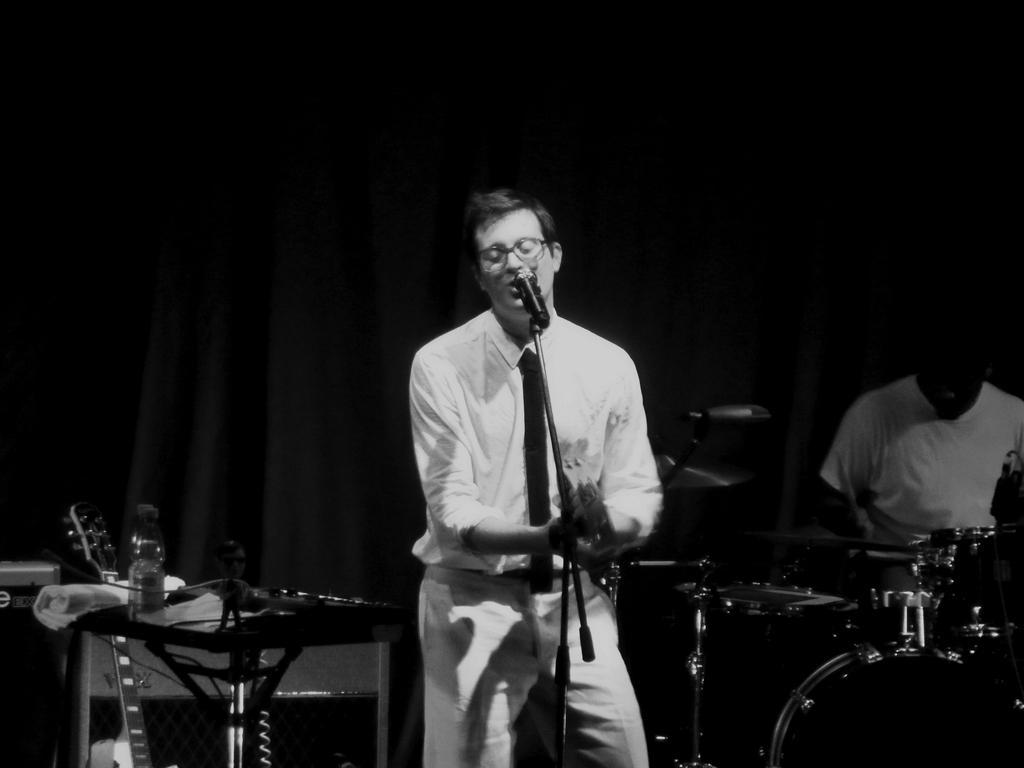Describe this image in one or two sentences. In the image there is a man infront singing on mic, and playing guitar and right side there is a man playing drum, 